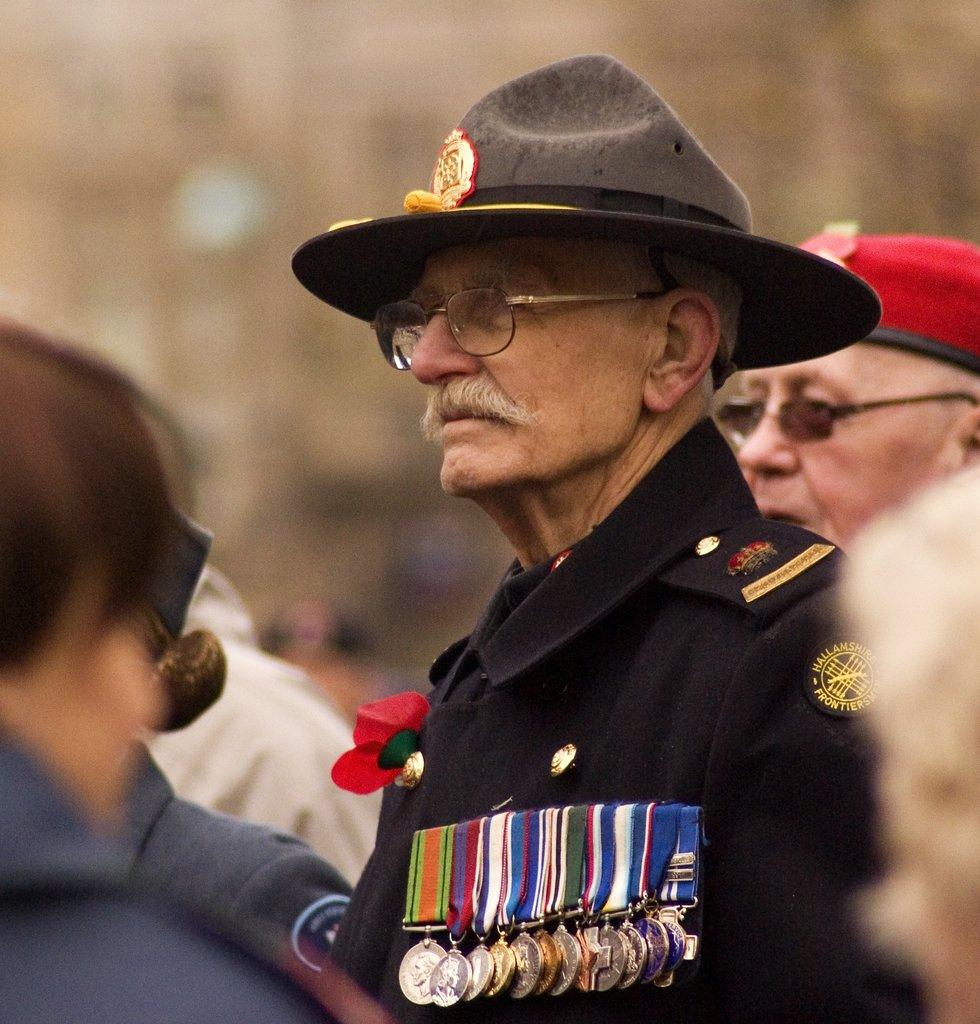What can be seen in the foreground of the image? There is a person in the image with a blurred background. What is the person in the foreground wearing? The person is wearing medals and a hat. Can you describe the person on the right side of the image? The second person is wearing spectacles and a cap. How many thumbs can be seen on the person in the image? The image does not show the person's thumbs, so it cannot be determined from the image. 